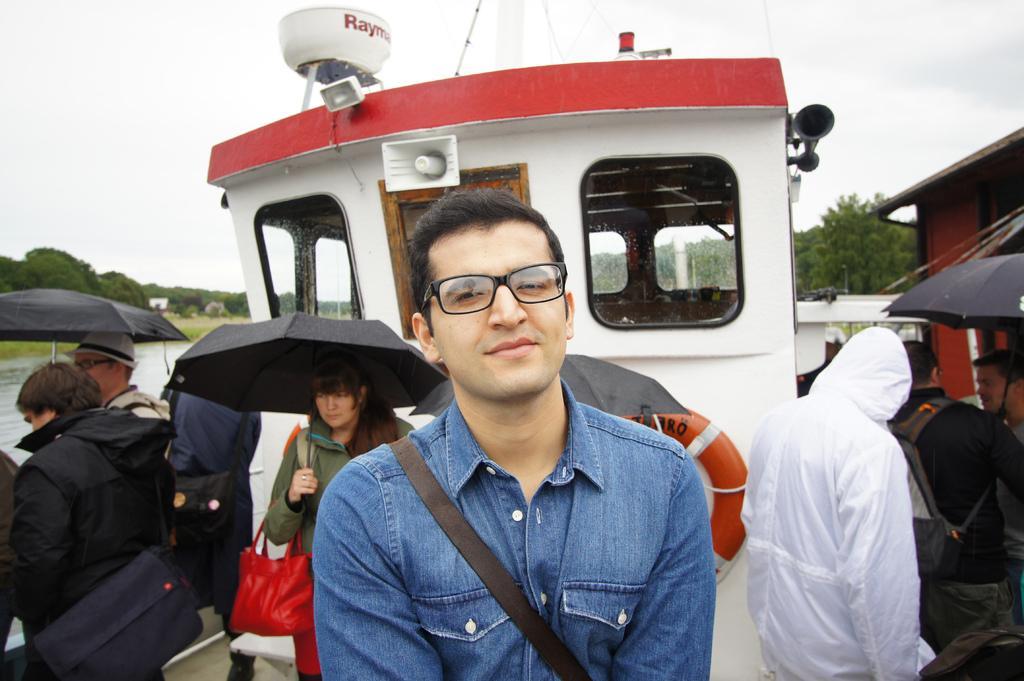Could you give a brief overview of what you see in this image? In this picture we can see a boat, there are some people standing in the boat, some of them are holding umbrellas, we can see water on the left side, in the background there are some trees, we can see the sky at the top of the picture. 